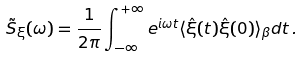Convert formula to latex. <formula><loc_0><loc_0><loc_500><loc_500>\tilde { S } _ { \xi } ( \omega ) = \frac { 1 } { 2 \pi } \int _ { - \infty } ^ { + \infty } e ^ { i \omega t } \langle \hat { \xi } ( t ) \hat { \xi } ( 0 ) \rangle _ { \beta } d t \, .</formula> 